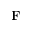Convert formula to latex. <formula><loc_0><loc_0><loc_500><loc_500>F</formula> 